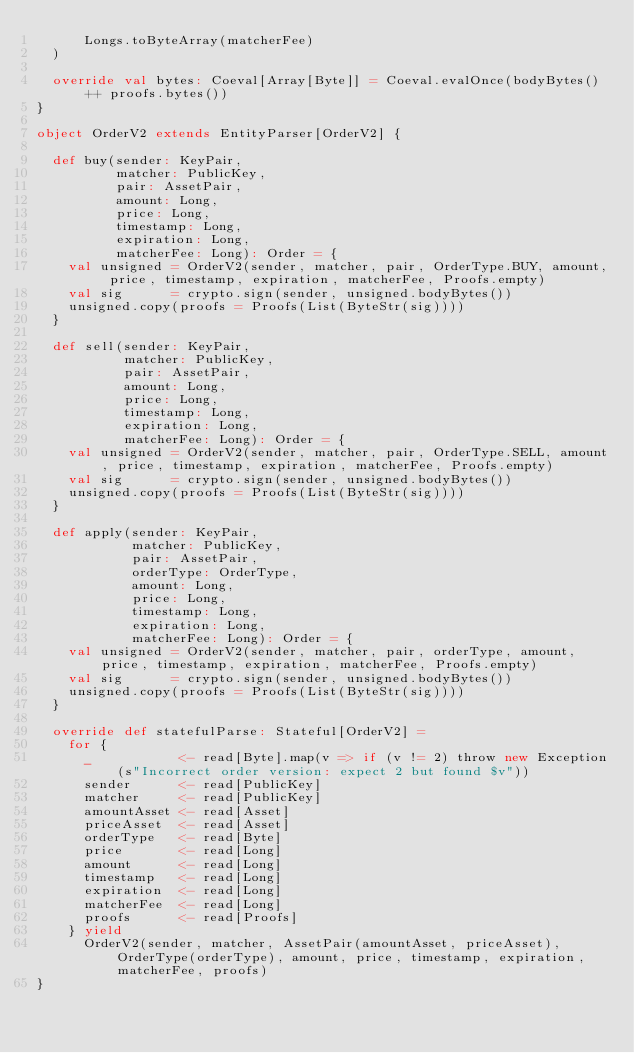Convert code to text. <code><loc_0><loc_0><loc_500><loc_500><_Scala_>      Longs.toByteArray(matcherFee)
  )

  override val bytes: Coeval[Array[Byte]] = Coeval.evalOnce(bodyBytes() ++ proofs.bytes())
}

object OrderV2 extends EntityParser[OrderV2] {

  def buy(sender: KeyPair,
          matcher: PublicKey,
          pair: AssetPair,
          amount: Long,
          price: Long,
          timestamp: Long,
          expiration: Long,
          matcherFee: Long): Order = {
    val unsigned = OrderV2(sender, matcher, pair, OrderType.BUY, amount, price, timestamp, expiration, matcherFee, Proofs.empty)
    val sig      = crypto.sign(sender, unsigned.bodyBytes())
    unsigned.copy(proofs = Proofs(List(ByteStr(sig))))
  }

  def sell(sender: KeyPair,
           matcher: PublicKey,
           pair: AssetPair,
           amount: Long,
           price: Long,
           timestamp: Long,
           expiration: Long,
           matcherFee: Long): Order = {
    val unsigned = OrderV2(sender, matcher, pair, OrderType.SELL, amount, price, timestamp, expiration, matcherFee, Proofs.empty)
    val sig      = crypto.sign(sender, unsigned.bodyBytes())
    unsigned.copy(proofs = Proofs(List(ByteStr(sig))))
  }

  def apply(sender: KeyPair,
            matcher: PublicKey,
            pair: AssetPair,
            orderType: OrderType,
            amount: Long,
            price: Long,
            timestamp: Long,
            expiration: Long,
            matcherFee: Long): Order = {
    val unsigned = OrderV2(sender, matcher, pair, orderType, amount, price, timestamp, expiration, matcherFee, Proofs.empty)
    val sig      = crypto.sign(sender, unsigned.bodyBytes())
    unsigned.copy(proofs = Proofs(List(ByteStr(sig))))
  }

  override def statefulParse: Stateful[OrderV2] =
    for {
      _           <- read[Byte].map(v => if (v != 2) throw new Exception(s"Incorrect order version: expect 2 but found $v"))
      sender      <- read[PublicKey]
      matcher     <- read[PublicKey]
      amountAsset <- read[Asset]
      priceAsset  <- read[Asset]
      orderType   <- read[Byte]
      price       <- read[Long]
      amount      <- read[Long]
      timestamp   <- read[Long]
      expiration  <- read[Long]
      matcherFee  <- read[Long]
      proofs      <- read[Proofs]
    } yield
      OrderV2(sender, matcher, AssetPair(amountAsset, priceAsset), OrderType(orderType), amount, price, timestamp, expiration, matcherFee, proofs)
}
</code> 